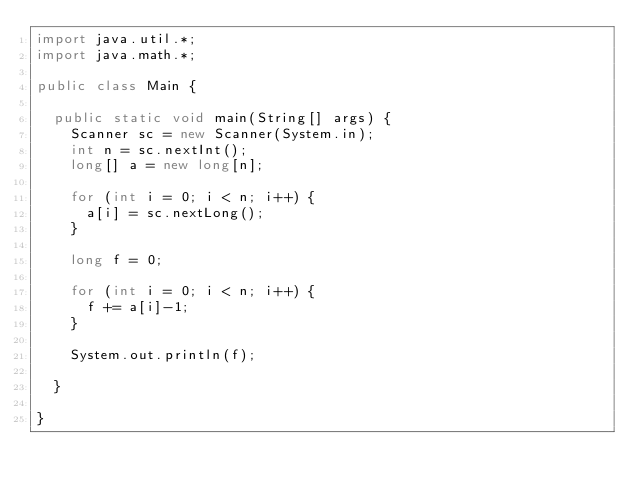Convert code to text. <code><loc_0><loc_0><loc_500><loc_500><_Java_>import java.util.*;
import java.math.*;

public class Main {

  public static void main(String[] args) {
    Scanner sc = new Scanner(System.in);
    int n = sc.nextInt();
    long[] a = new long[n];

    for (int i = 0; i < n; i++) {
      a[i] = sc.nextLong();
    }

    long f = 0;

    for (int i = 0; i < n; i++) {
      f += a[i]-1;
    }

    System.out.println(f);

  }

}
</code> 